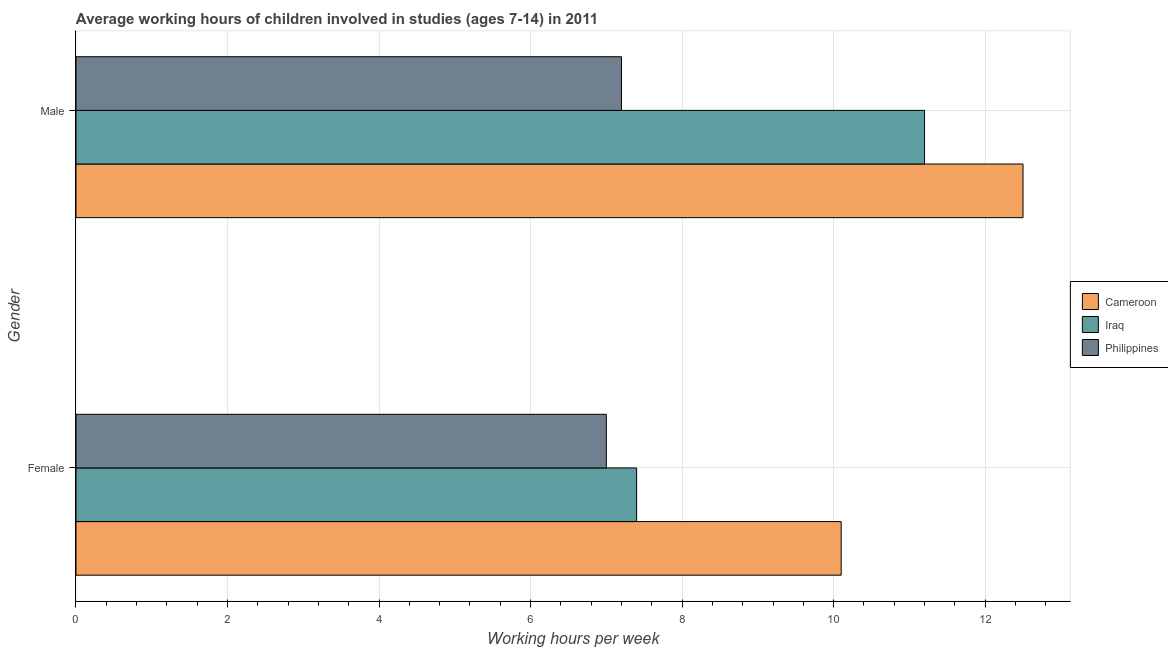How many different coloured bars are there?
Provide a succinct answer. 3. Are the number of bars per tick equal to the number of legend labels?
Your response must be concise. Yes. How many bars are there on the 2nd tick from the bottom?
Ensure brevity in your answer.  3. What is the label of the 1st group of bars from the top?
Your response must be concise. Male. Across all countries, what is the maximum average working hour of female children?
Your response must be concise. 10.1. Across all countries, what is the minimum average working hour of male children?
Make the answer very short. 7.2. In which country was the average working hour of male children maximum?
Make the answer very short. Cameroon. What is the total average working hour of male children in the graph?
Your response must be concise. 30.9. What is the difference between the average working hour of female children in Cameroon and that in Iraq?
Keep it short and to the point. 2.7. What is the difference between the average working hour of female children in Cameroon and the average working hour of male children in Philippines?
Your answer should be compact. 2.9. What is the average average working hour of male children per country?
Offer a very short reply. 10.3. What is the difference between the average working hour of male children and average working hour of female children in Iraq?
Your response must be concise. 3.8. In how many countries, is the average working hour of female children greater than 0.4 hours?
Your response must be concise. 3. What is the ratio of the average working hour of male children in Iraq to that in Cameroon?
Make the answer very short. 0.9. What does the 2nd bar from the top in Male represents?
Offer a terse response. Iraq. What does the 1st bar from the bottom in Male represents?
Your response must be concise. Cameroon. How many bars are there?
Provide a short and direct response. 6. Are the values on the major ticks of X-axis written in scientific E-notation?
Make the answer very short. No. Does the graph contain any zero values?
Your response must be concise. No. Does the graph contain grids?
Offer a terse response. Yes. What is the title of the graph?
Make the answer very short. Average working hours of children involved in studies (ages 7-14) in 2011. Does "High income: nonOECD" appear as one of the legend labels in the graph?
Your answer should be compact. No. What is the label or title of the X-axis?
Provide a short and direct response. Working hours per week. What is the Working hours per week in Cameroon in Female?
Provide a short and direct response. 10.1. What is the Working hours per week of Iraq in Female?
Give a very brief answer. 7.4. What is the Working hours per week in Iraq in Male?
Keep it short and to the point. 11.2. What is the Working hours per week of Philippines in Male?
Offer a terse response. 7.2. Across all Gender, what is the maximum Working hours per week of Cameroon?
Ensure brevity in your answer.  12.5. Across all Gender, what is the maximum Working hours per week of Iraq?
Your answer should be compact. 11.2. Across all Gender, what is the minimum Working hours per week in Iraq?
Your response must be concise. 7.4. What is the total Working hours per week in Cameroon in the graph?
Ensure brevity in your answer.  22.6. What is the total Working hours per week of Philippines in the graph?
Offer a very short reply. 14.2. What is the difference between the Working hours per week in Cameroon in Female and that in Male?
Your answer should be very brief. -2.4. What is the difference between the Working hours per week of Philippines in Female and that in Male?
Offer a terse response. -0.2. What is the difference between the Working hours per week of Cameroon in Female and the Working hours per week of Philippines in Male?
Your answer should be very brief. 2.9. What is the difference between the Working hours per week of Cameroon and Working hours per week of Iraq in Female?
Your answer should be very brief. 2.7. What is the difference between the Working hours per week of Cameroon and Working hours per week of Philippines in Female?
Offer a very short reply. 3.1. What is the difference between the Working hours per week in Iraq and Working hours per week in Philippines in Female?
Provide a succinct answer. 0.4. What is the difference between the Working hours per week in Cameroon and Working hours per week in Iraq in Male?
Offer a terse response. 1.3. What is the difference between the Working hours per week in Cameroon and Working hours per week in Philippines in Male?
Keep it short and to the point. 5.3. What is the ratio of the Working hours per week of Cameroon in Female to that in Male?
Your answer should be very brief. 0.81. What is the ratio of the Working hours per week of Iraq in Female to that in Male?
Provide a succinct answer. 0.66. What is the ratio of the Working hours per week of Philippines in Female to that in Male?
Your answer should be very brief. 0.97. What is the difference between the highest and the second highest Working hours per week of Iraq?
Provide a short and direct response. 3.8. What is the difference between the highest and the second highest Working hours per week of Philippines?
Ensure brevity in your answer.  0.2. What is the difference between the highest and the lowest Working hours per week in Philippines?
Offer a very short reply. 0.2. 